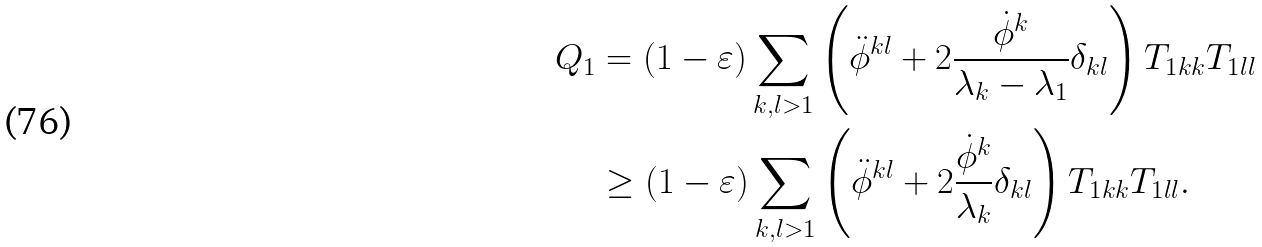<formula> <loc_0><loc_0><loc_500><loc_500>Q _ { 1 } & = ( 1 - \varepsilon ) \sum _ { k , l > 1 } \left ( \ddot { \phi } ^ { k l } + 2 \frac { \dot { \phi } ^ { k } } { \lambda _ { k } - \lambda _ { 1 } } \delta _ { k l } \right ) T _ { 1 k k } T _ { 1 l l } \\ & \geq ( 1 - \varepsilon ) \sum _ { k , l > 1 } \left ( \ddot { \phi } ^ { k l } + 2 \frac { \dot { \phi } ^ { k } } { \lambda _ { k } } \delta _ { k l } \right ) T _ { 1 k k } T _ { 1 l l } .</formula> 